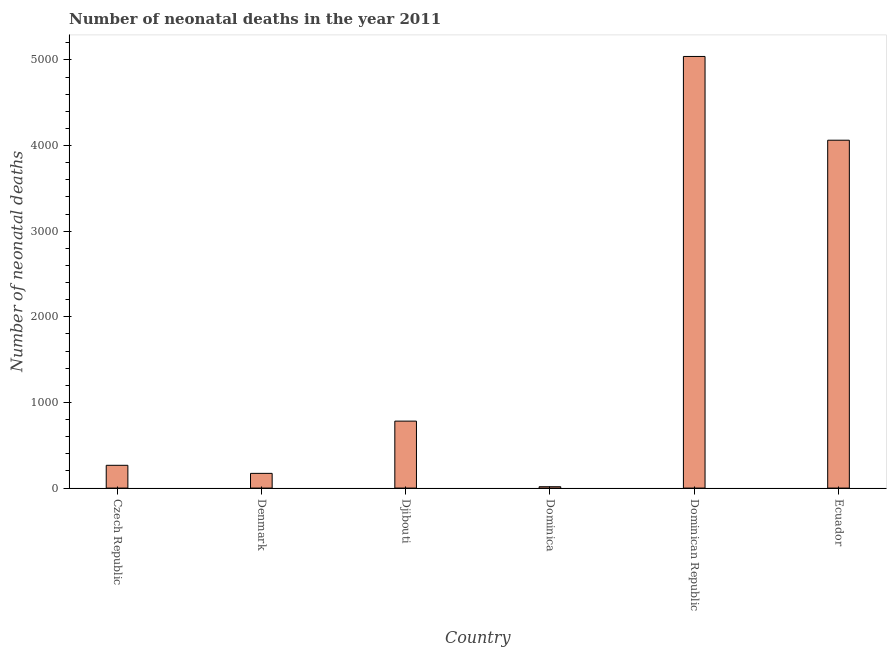Does the graph contain grids?
Provide a succinct answer. No. What is the title of the graph?
Give a very brief answer. Number of neonatal deaths in the year 2011. What is the label or title of the Y-axis?
Give a very brief answer. Number of neonatal deaths. What is the number of neonatal deaths in Ecuador?
Your response must be concise. 4062. Across all countries, what is the maximum number of neonatal deaths?
Your response must be concise. 5040. In which country was the number of neonatal deaths maximum?
Offer a very short reply. Dominican Republic. In which country was the number of neonatal deaths minimum?
Provide a short and direct response. Dominica. What is the sum of the number of neonatal deaths?
Offer a very short reply. 1.03e+04. What is the difference between the number of neonatal deaths in Denmark and Djibouti?
Ensure brevity in your answer.  -610. What is the average number of neonatal deaths per country?
Make the answer very short. 1723. What is the median number of neonatal deaths?
Provide a succinct answer. 524. What is the ratio of the number of neonatal deaths in Djibouti to that in Ecuador?
Offer a terse response. 0.19. Is the number of neonatal deaths in Djibouti less than that in Dominican Republic?
Offer a very short reply. Yes. Is the difference between the number of neonatal deaths in Denmark and Djibouti greater than the difference between any two countries?
Your answer should be compact. No. What is the difference between the highest and the second highest number of neonatal deaths?
Your answer should be compact. 978. What is the difference between the highest and the lowest number of neonatal deaths?
Offer a very short reply. 5024. In how many countries, is the number of neonatal deaths greater than the average number of neonatal deaths taken over all countries?
Make the answer very short. 2. How many countries are there in the graph?
Your answer should be compact. 6. What is the Number of neonatal deaths of Czech Republic?
Keep it short and to the point. 266. What is the Number of neonatal deaths in Denmark?
Your answer should be compact. 172. What is the Number of neonatal deaths in Djibouti?
Your answer should be compact. 782. What is the Number of neonatal deaths of Dominica?
Provide a short and direct response. 16. What is the Number of neonatal deaths of Dominican Republic?
Make the answer very short. 5040. What is the Number of neonatal deaths in Ecuador?
Give a very brief answer. 4062. What is the difference between the Number of neonatal deaths in Czech Republic and Denmark?
Provide a short and direct response. 94. What is the difference between the Number of neonatal deaths in Czech Republic and Djibouti?
Offer a terse response. -516. What is the difference between the Number of neonatal deaths in Czech Republic and Dominica?
Ensure brevity in your answer.  250. What is the difference between the Number of neonatal deaths in Czech Republic and Dominican Republic?
Your response must be concise. -4774. What is the difference between the Number of neonatal deaths in Czech Republic and Ecuador?
Make the answer very short. -3796. What is the difference between the Number of neonatal deaths in Denmark and Djibouti?
Keep it short and to the point. -610. What is the difference between the Number of neonatal deaths in Denmark and Dominica?
Your answer should be compact. 156. What is the difference between the Number of neonatal deaths in Denmark and Dominican Republic?
Your answer should be compact. -4868. What is the difference between the Number of neonatal deaths in Denmark and Ecuador?
Give a very brief answer. -3890. What is the difference between the Number of neonatal deaths in Djibouti and Dominica?
Offer a terse response. 766. What is the difference between the Number of neonatal deaths in Djibouti and Dominican Republic?
Your answer should be compact. -4258. What is the difference between the Number of neonatal deaths in Djibouti and Ecuador?
Provide a short and direct response. -3280. What is the difference between the Number of neonatal deaths in Dominica and Dominican Republic?
Offer a very short reply. -5024. What is the difference between the Number of neonatal deaths in Dominica and Ecuador?
Your answer should be very brief. -4046. What is the difference between the Number of neonatal deaths in Dominican Republic and Ecuador?
Make the answer very short. 978. What is the ratio of the Number of neonatal deaths in Czech Republic to that in Denmark?
Ensure brevity in your answer.  1.55. What is the ratio of the Number of neonatal deaths in Czech Republic to that in Djibouti?
Your answer should be very brief. 0.34. What is the ratio of the Number of neonatal deaths in Czech Republic to that in Dominica?
Provide a short and direct response. 16.62. What is the ratio of the Number of neonatal deaths in Czech Republic to that in Dominican Republic?
Make the answer very short. 0.05. What is the ratio of the Number of neonatal deaths in Czech Republic to that in Ecuador?
Your response must be concise. 0.07. What is the ratio of the Number of neonatal deaths in Denmark to that in Djibouti?
Make the answer very short. 0.22. What is the ratio of the Number of neonatal deaths in Denmark to that in Dominica?
Ensure brevity in your answer.  10.75. What is the ratio of the Number of neonatal deaths in Denmark to that in Dominican Republic?
Your answer should be compact. 0.03. What is the ratio of the Number of neonatal deaths in Denmark to that in Ecuador?
Your response must be concise. 0.04. What is the ratio of the Number of neonatal deaths in Djibouti to that in Dominica?
Your answer should be compact. 48.88. What is the ratio of the Number of neonatal deaths in Djibouti to that in Dominican Republic?
Offer a terse response. 0.15. What is the ratio of the Number of neonatal deaths in Djibouti to that in Ecuador?
Give a very brief answer. 0.19. What is the ratio of the Number of neonatal deaths in Dominica to that in Dominican Republic?
Offer a very short reply. 0. What is the ratio of the Number of neonatal deaths in Dominica to that in Ecuador?
Provide a short and direct response. 0. What is the ratio of the Number of neonatal deaths in Dominican Republic to that in Ecuador?
Make the answer very short. 1.24. 